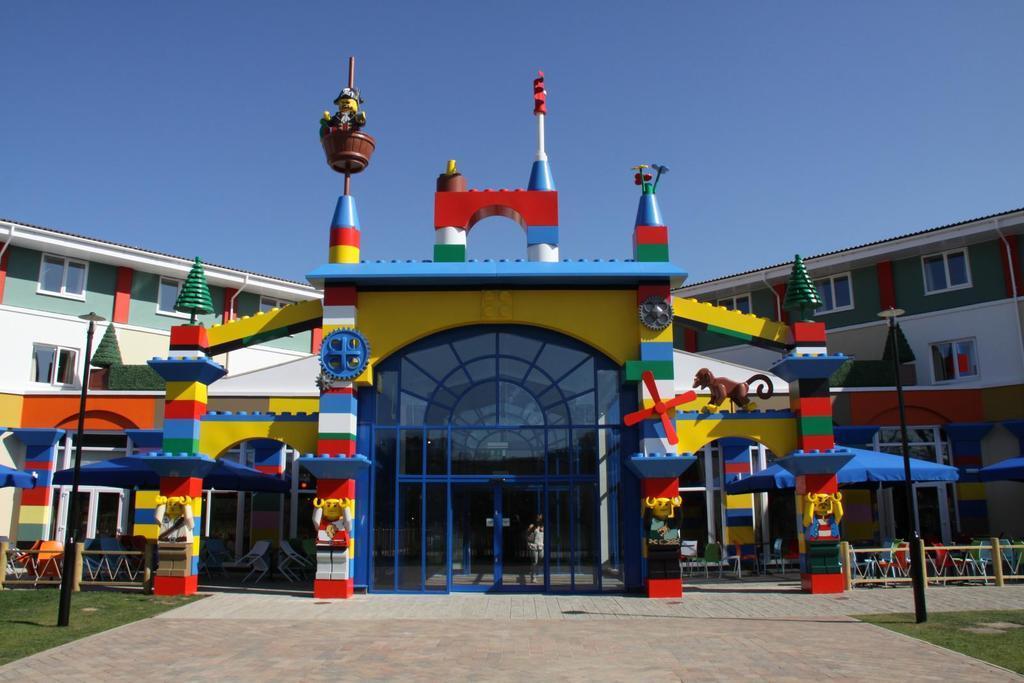Can you describe this image briefly? In this image in the center there is a building, and also there are some toys, railing, glass doors, poles, pillars and on the right side and left side there is a railing. At the bottom there is grass and walkway, at the top of the image there is sky. 